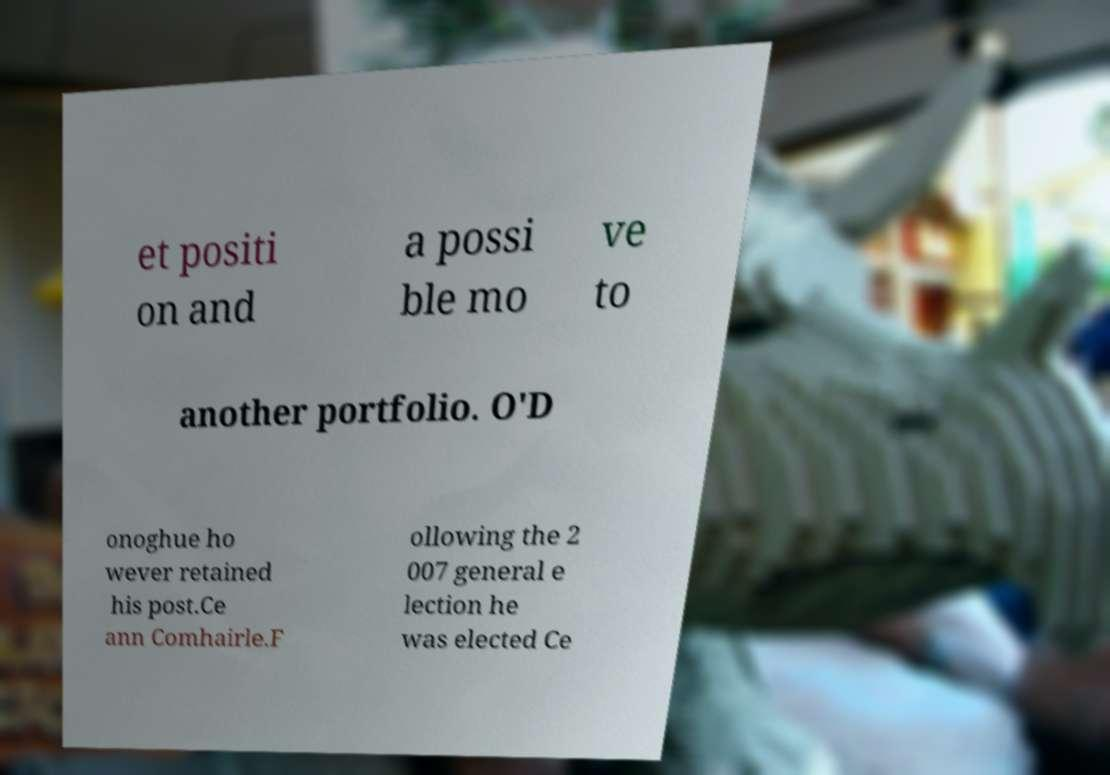Please read and relay the text visible in this image. What does it say? et positi on and a possi ble mo ve to another portfolio. O'D onoghue ho wever retained his post.Ce ann Comhairle.F ollowing the 2 007 general e lection he was elected Ce 